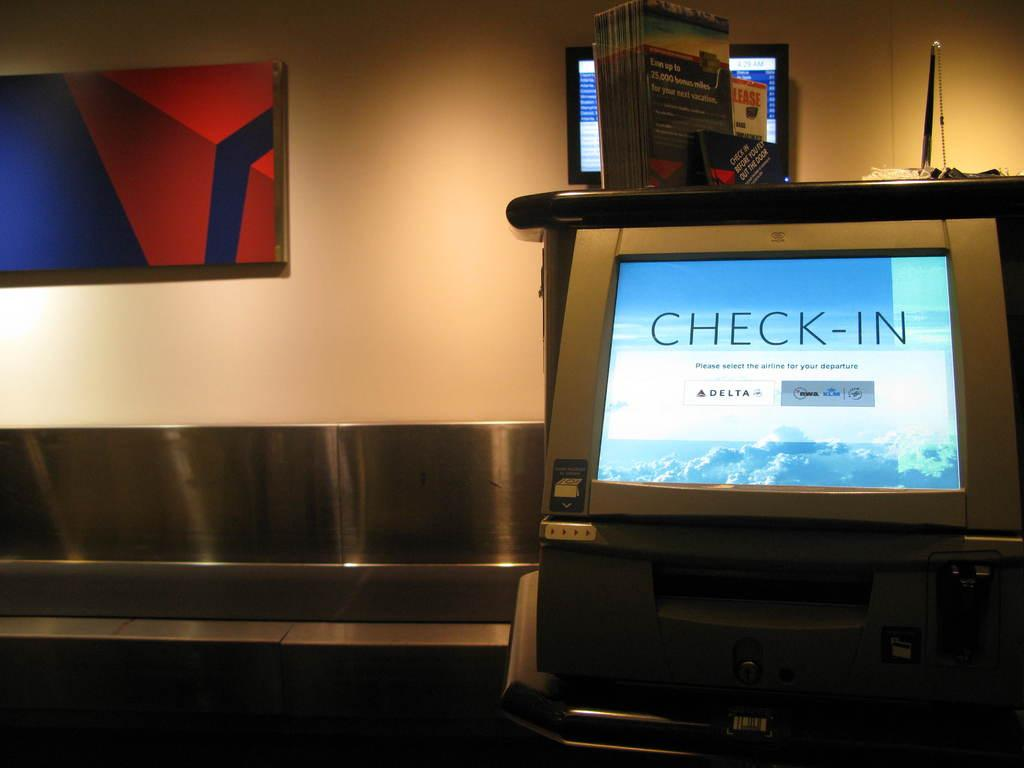<image>
Offer a succinct explanation of the picture presented. An electronic display offers services related to the Check-In procedure. 